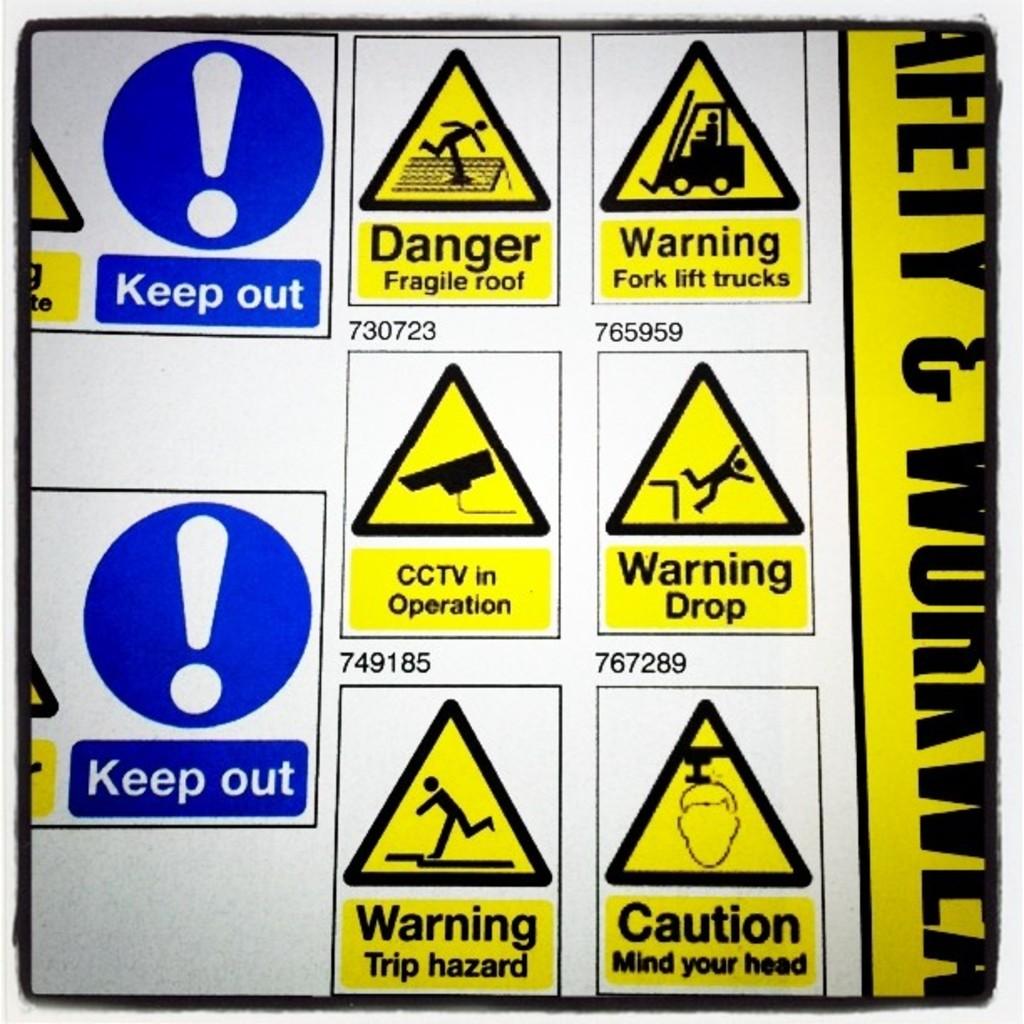What is dangerous?
Make the answer very short. Fragile roof. What does it say under the exclamation point?
Make the answer very short. Keep out. 